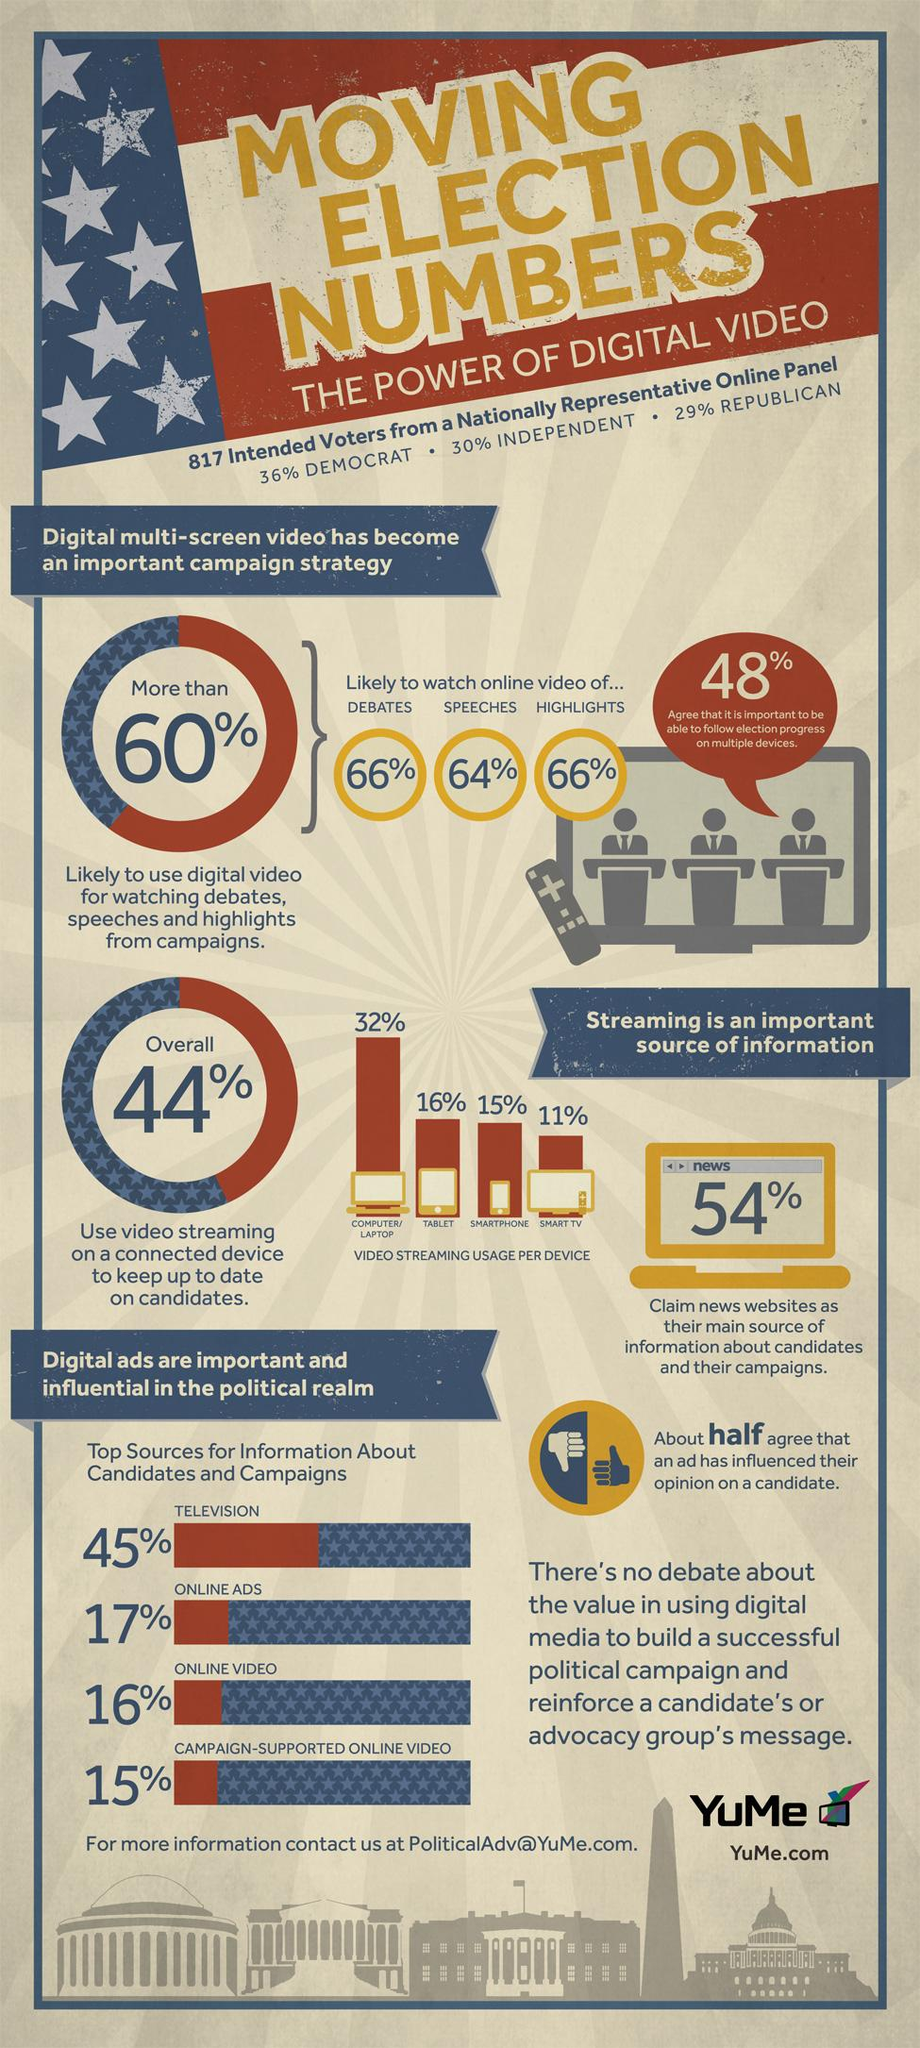Indicate a few pertinent items in this graphic. Approximately 17% of the information about candidates and their campaigns is sourced from online ads. 